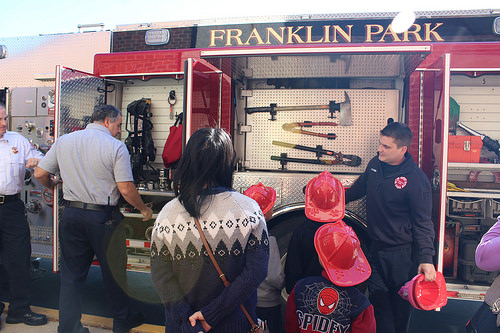<image>
Is the woman behind the boy? Yes. From this viewpoint, the woman is positioned behind the boy, with the boy partially or fully occluding the woman. 